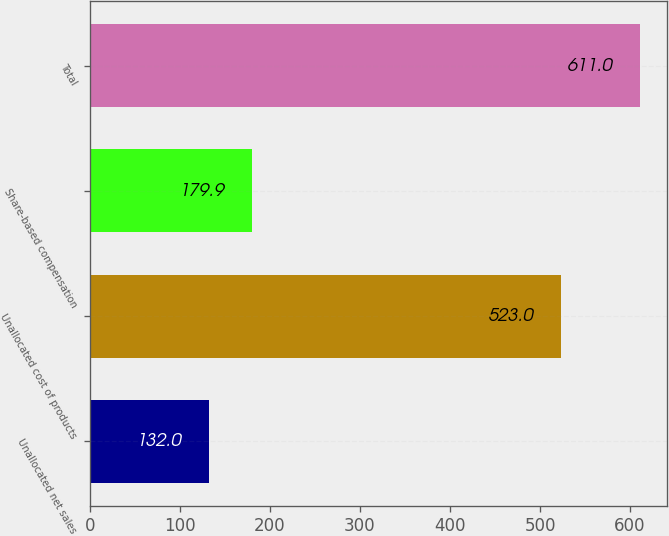<chart> <loc_0><loc_0><loc_500><loc_500><bar_chart><fcel>Unallocated net sales<fcel>Unallocated cost of products<fcel>Share-based compensation<fcel>Total<nl><fcel>132<fcel>523<fcel>179.9<fcel>611<nl></chart> 